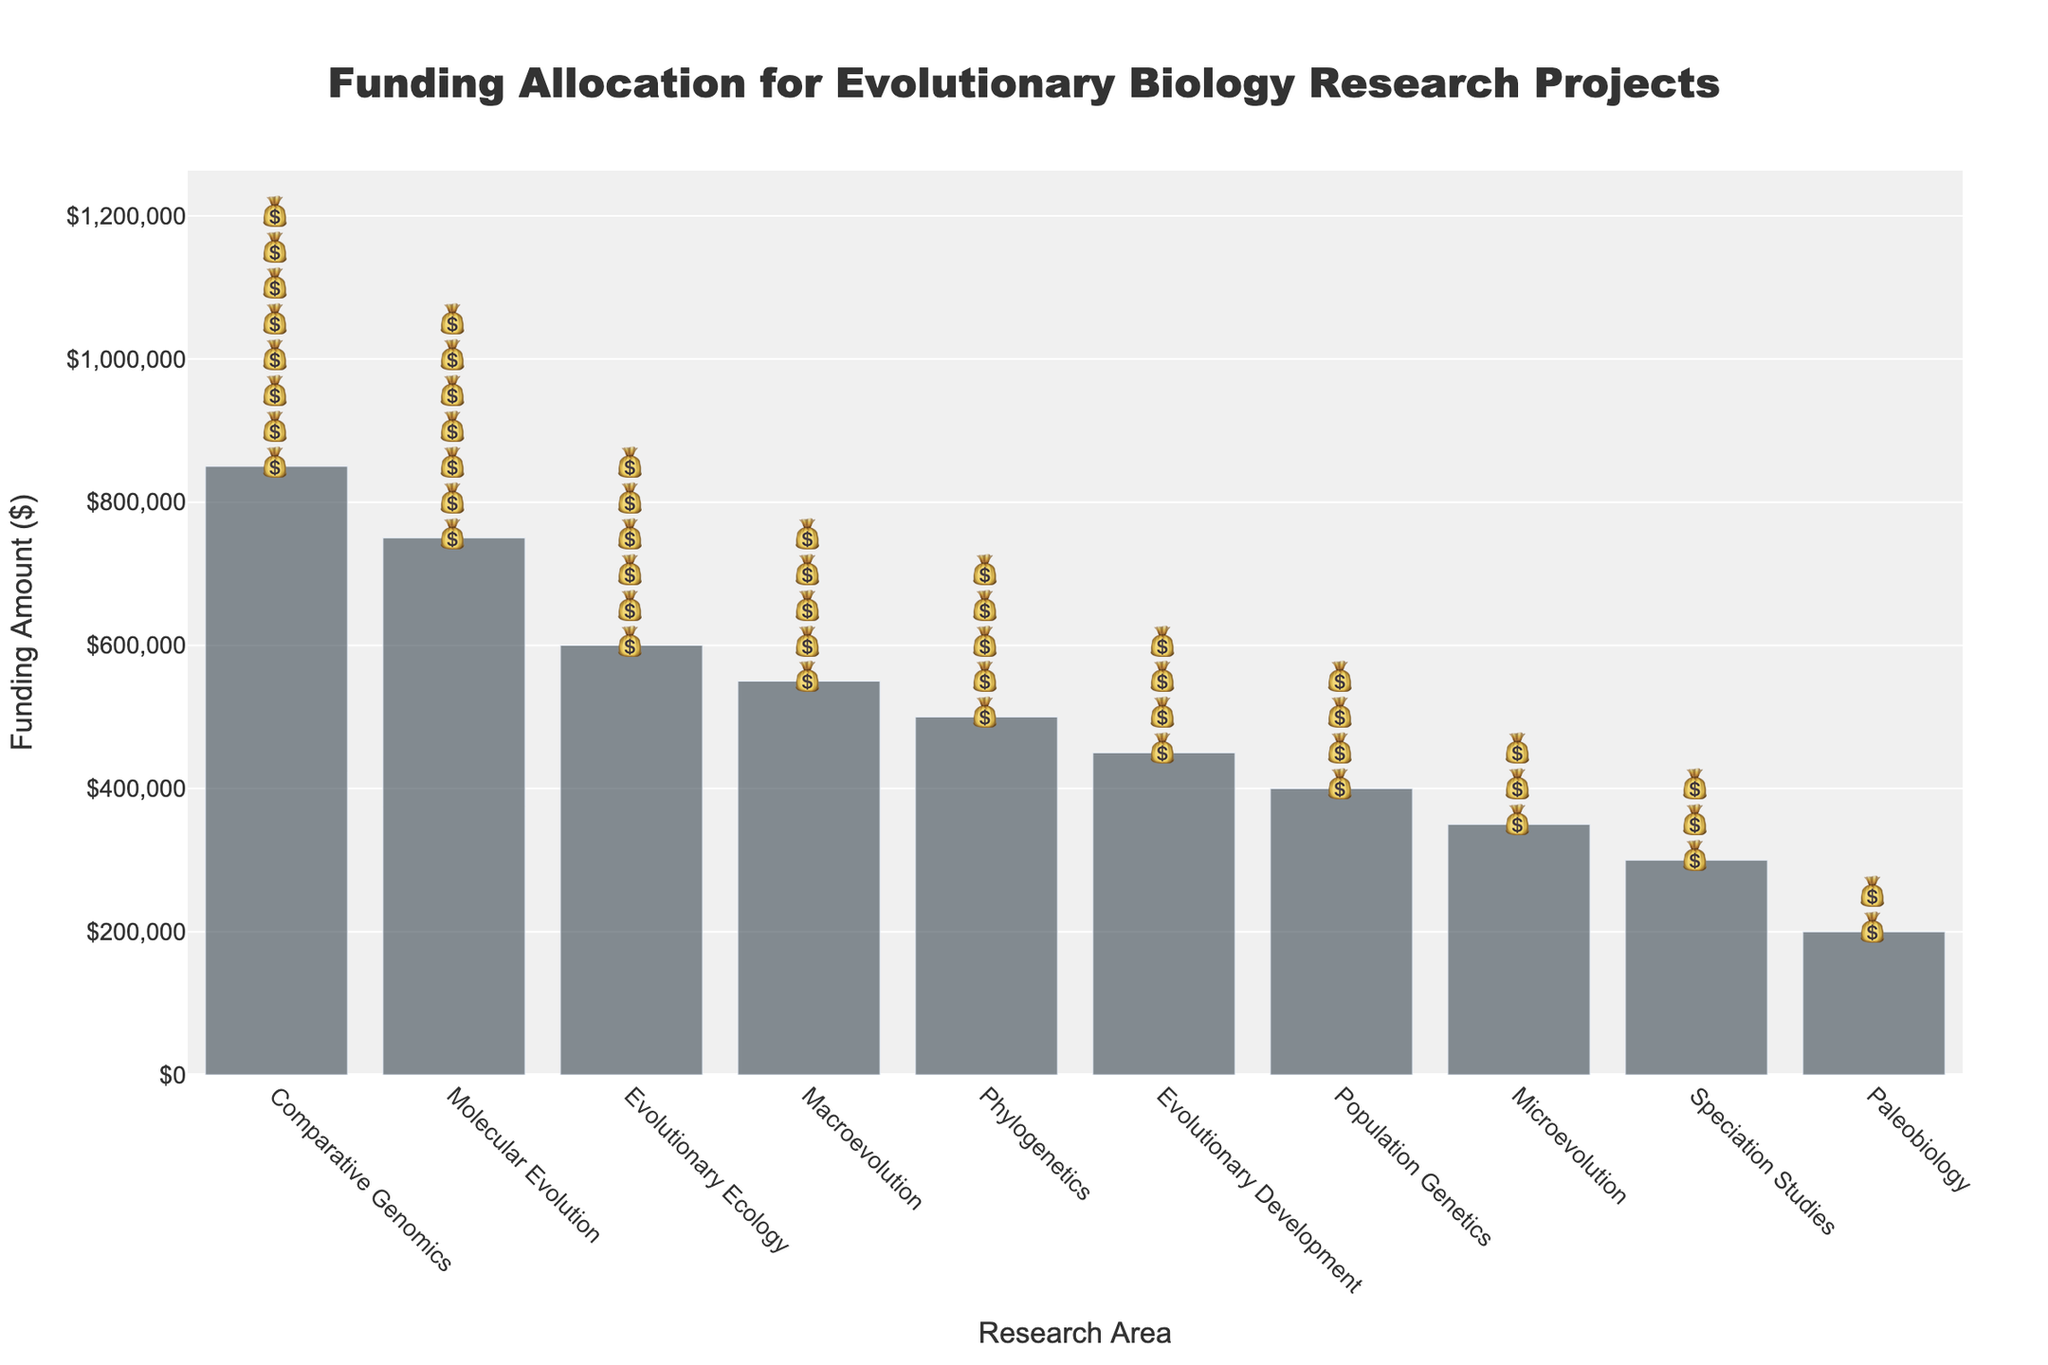How many research areas are presented in the figure? Count the number of different research areas listed on the x-axis of the figure.
Answer: 10 What is the total funding amount for Speciation Studies and Paleobiology? Locate the funding amounts for Speciation Studies and Paleobiology on the y-axis. Add them together: 300,000 + 200,000 = 500,000.
Answer: 500,000 Which research area received the highest funding? Identify the bar that reaches the highest value on the y-axis.
Answer: Comparative Genomics How many grant icons are shown for Molecular Evolution? Count the number of 💰 icons for Molecular Evolution.
Answer: 7 What's the funding difference between Evolutionary Ecology and Microevolution? Subtract the funding amount of Microevolution from Evolutionary Ecology: 600,000 - 350,000 = 250,000.
Answer: 250,000 Which research area received less funding: Macroevolution or Population Genetics? Compare the heights of the bar for Macroevolution and Population Genetics on the y-axis.
Answer: Population Genetics What's the total number of grant icons displayed across all research areas? Add up all the grant icons for each research area: 5 + 7 + 4 + 3 + 6 + 2 + 8 + 4 + 3 + 5 = 47.
Answer: 47 How much more funding did Comparative Genomics receive compared to Phylogenetics? Subtract the funding amount of Phylogenetics from Comparative Genomics: 850,000 - 500,000 = 350,000.
Answer: 350,000 What's the average funding amount across all research areas? Sum all the funding amounts and divide by the number of research areas: (500,000 + 750,000 + 400,000 + 300,000 + 600,000 + 200,000 + 850,000 + 450,000 + 350,000 + 550,000) / 10 = 495,000.
Answer: 495,000 Which research areas received the same number of grant icons? Identify the research areas with matching numbers of 💰 icons.
Answer: Population Genetics and Evolutionary Development 